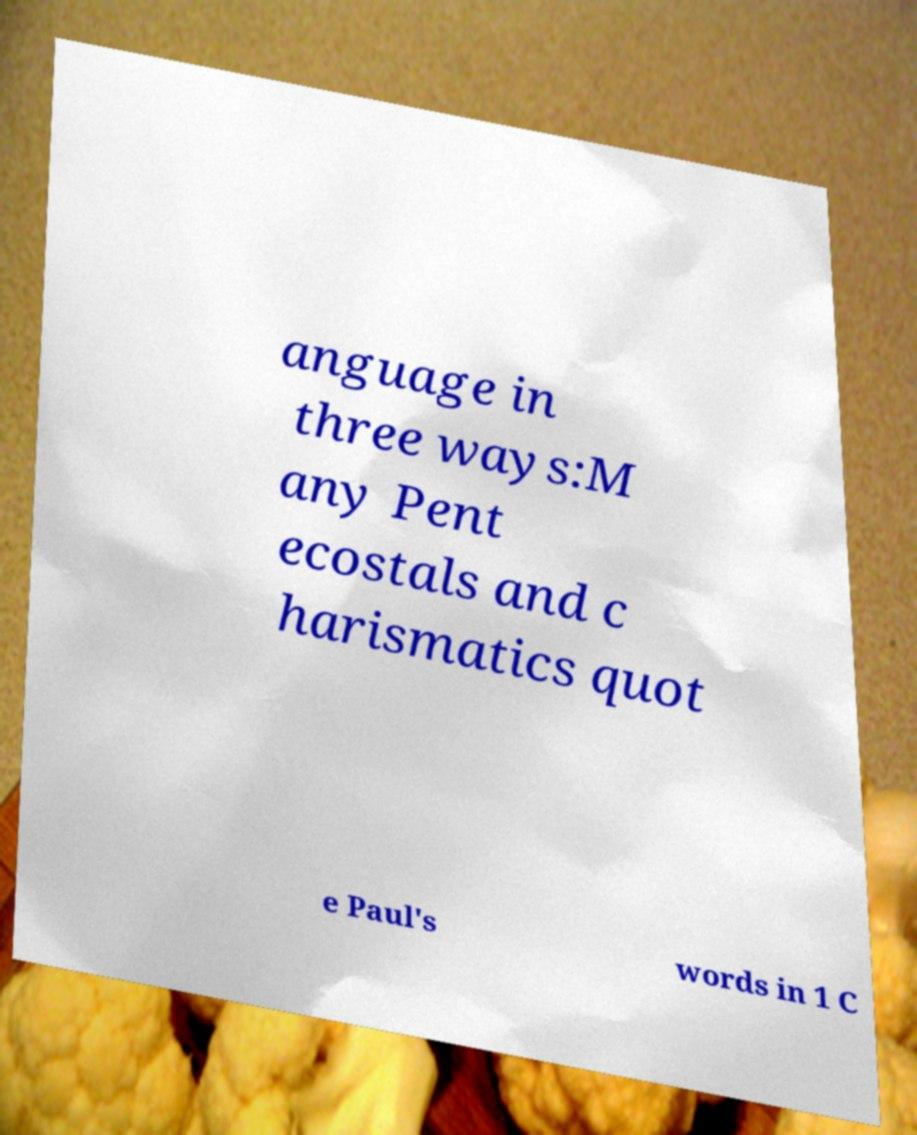There's text embedded in this image that I need extracted. Can you transcribe it verbatim? anguage in three ways:M any Pent ecostals and c harismatics quot e Paul's words in 1 C 